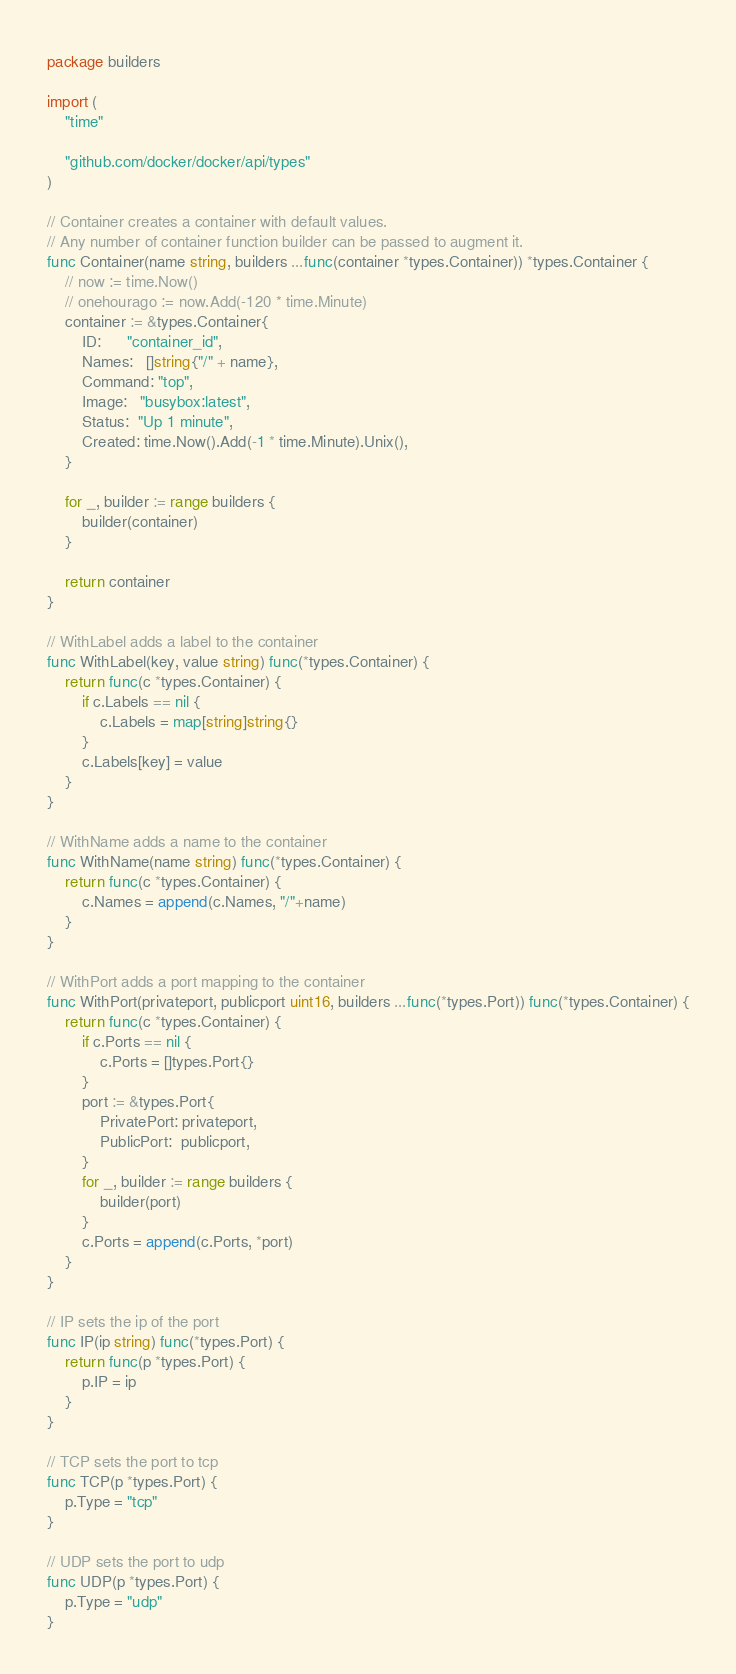Convert code to text. <code><loc_0><loc_0><loc_500><loc_500><_Go_>package builders

import (
	"time"

	"github.com/docker/docker/api/types"
)

// Container creates a container with default values.
// Any number of container function builder can be passed to augment it.
func Container(name string, builders ...func(container *types.Container)) *types.Container {
	// now := time.Now()
	// onehourago := now.Add(-120 * time.Minute)
	container := &types.Container{
		ID:      "container_id",
		Names:   []string{"/" + name},
		Command: "top",
		Image:   "busybox:latest",
		Status:  "Up 1 minute",
		Created: time.Now().Add(-1 * time.Minute).Unix(),
	}

	for _, builder := range builders {
		builder(container)
	}

	return container
}

// WithLabel adds a label to the container
func WithLabel(key, value string) func(*types.Container) {
	return func(c *types.Container) {
		if c.Labels == nil {
			c.Labels = map[string]string{}
		}
		c.Labels[key] = value
	}
}

// WithName adds a name to the container
func WithName(name string) func(*types.Container) {
	return func(c *types.Container) {
		c.Names = append(c.Names, "/"+name)
	}
}

// WithPort adds a port mapping to the container
func WithPort(privateport, publicport uint16, builders ...func(*types.Port)) func(*types.Container) {
	return func(c *types.Container) {
		if c.Ports == nil {
			c.Ports = []types.Port{}
		}
		port := &types.Port{
			PrivatePort: privateport,
			PublicPort:  publicport,
		}
		for _, builder := range builders {
			builder(port)
		}
		c.Ports = append(c.Ports, *port)
	}
}

// IP sets the ip of the port
func IP(ip string) func(*types.Port) {
	return func(p *types.Port) {
		p.IP = ip
	}
}

// TCP sets the port to tcp
func TCP(p *types.Port) {
	p.Type = "tcp"
}

// UDP sets the port to udp
func UDP(p *types.Port) {
	p.Type = "udp"
}
</code> 